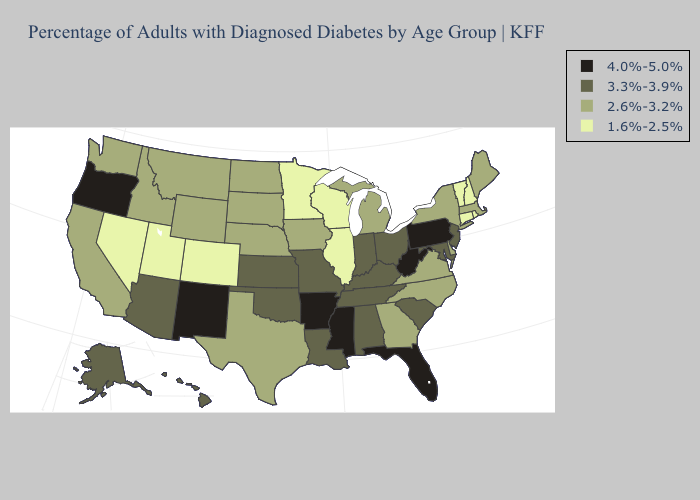Which states have the highest value in the USA?
Keep it brief. Arkansas, Florida, Mississippi, New Mexico, Oregon, Pennsylvania, West Virginia. Name the states that have a value in the range 3.3%-3.9%?
Write a very short answer. Alabama, Alaska, Arizona, Hawaii, Indiana, Kansas, Kentucky, Louisiana, Maryland, Missouri, New Jersey, Ohio, Oklahoma, South Carolina, Tennessee. Name the states that have a value in the range 4.0%-5.0%?
Give a very brief answer. Arkansas, Florida, Mississippi, New Mexico, Oregon, Pennsylvania, West Virginia. What is the highest value in the USA?
Quick response, please. 4.0%-5.0%. Name the states that have a value in the range 1.6%-2.5%?
Short answer required. Colorado, Connecticut, Illinois, Minnesota, Nevada, New Hampshire, Rhode Island, Utah, Vermont, Wisconsin. What is the value of Maryland?
Short answer required. 3.3%-3.9%. What is the value of West Virginia?
Short answer required. 4.0%-5.0%. What is the value of Illinois?
Quick response, please. 1.6%-2.5%. What is the highest value in the USA?
Concise answer only. 4.0%-5.0%. What is the value of Washington?
Keep it brief. 2.6%-3.2%. Name the states that have a value in the range 4.0%-5.0%?
Quick response, please. Arkansas, Florida, Mississippi, New Mexico, Oregon, Pennsylvania, West Virginia. Name the states that have a value in the range 4.0%-5.0%?
Short answer required. Arkansas, Florida, Mississippi, New Mexico, Oregon, Pennsylvania, West Virginia. Does Louisiana have the lowest value in the USA?
Give a very brief answer. No. What is the lowest value in the USA?
Give a very brief answer. 1.6%-2.5%. Does Oregon have the highest value in the USA?
Give a very brief answer. Yes. 